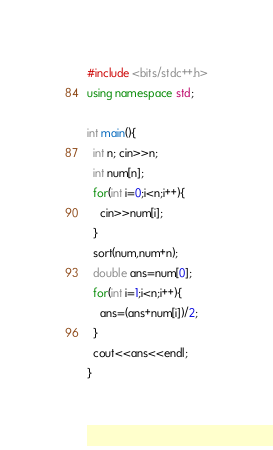<code> <loc_0><loc_0><loc_500><loc_500><_C++_>#include <bits/stdc++.h>
using namespace std;

int main(){
  int n; cin>>n;
  int num[n];
  for(int i=0;i<n;i++){
    cin>>num[i];
  }
  sort(num,num+n);
  double ans=num[0];
  for(int i=1;i<n;i++){
    ans=(ans+num[i])/2;
  }
  cout<<ans<<endl;
}
</code> 